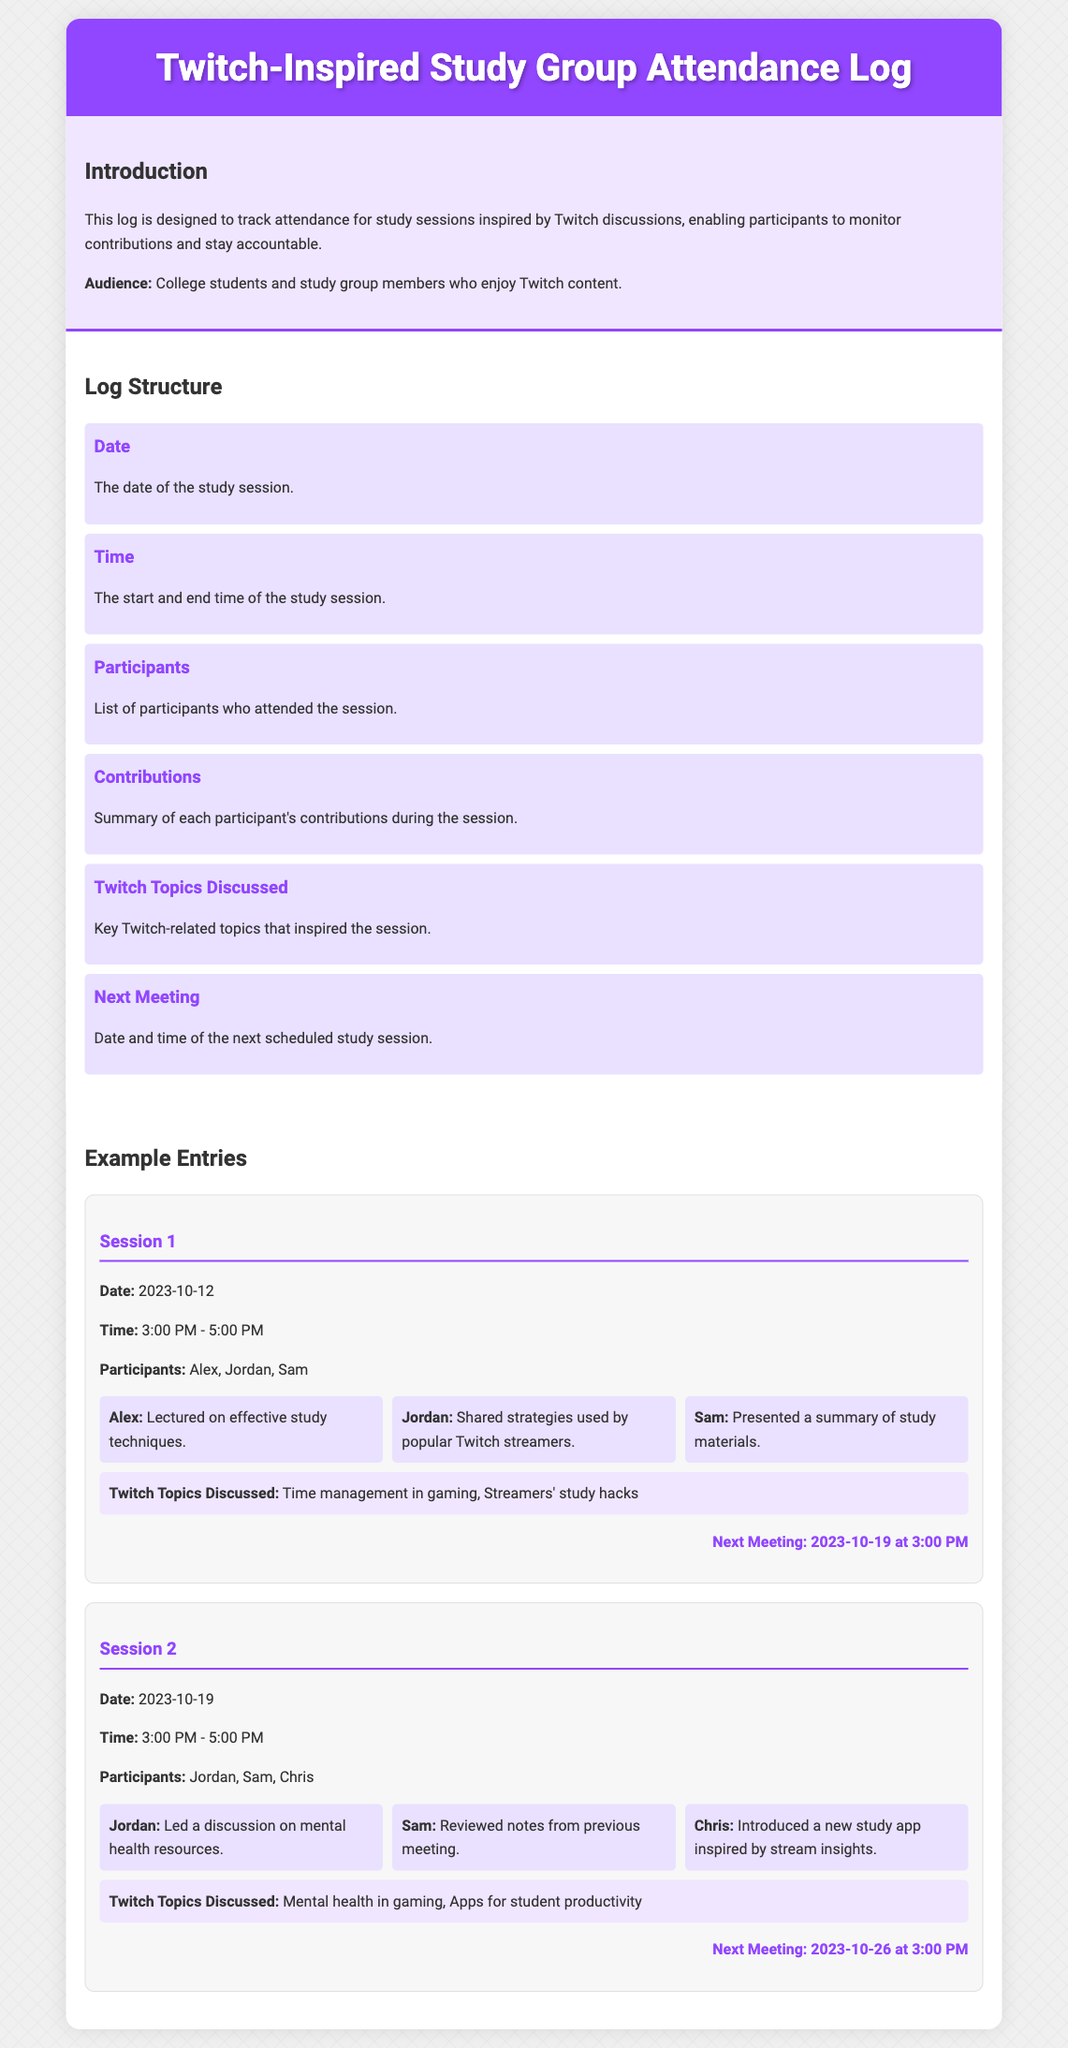What is the date of the first study session? The date of the first study session, as shown in the log, is directly stated in the details of Session 1.
Answer: 2023-10-12 Who presented the study materials in Session 1? The contributor who presented the study materials in Session 1 is mentioned under the contributions section.
Answer: Sam What was the duration of each study session? The duration for each session is given in the time details of the log entries for each session.
Answer: 2 hours What key topic related to Twitch was discussed in Session 2? Key topics discussed during Session 2 are mentioned in the corresponding section for that entry.
Answer: Mental health in gaming Who introduced a new study app? The participant who introduced the new study app is specified under the contributions for Session 2.
Answer: Chris What is the next meeting date after Session 1? The next meeting date is outlined in the meeting details at the conclusion of Session 1.
Answer: 2023-10-19 Which participant shared strategies used by popular Twitch streamers in Session 1? The participant who shared these strategies is explicitly named in the contributions for Session 1.
Answer: Jordan How many participants attended Session 2? The number of participants can be derived from the participants listed in Session 2's details.
Answer: 3 